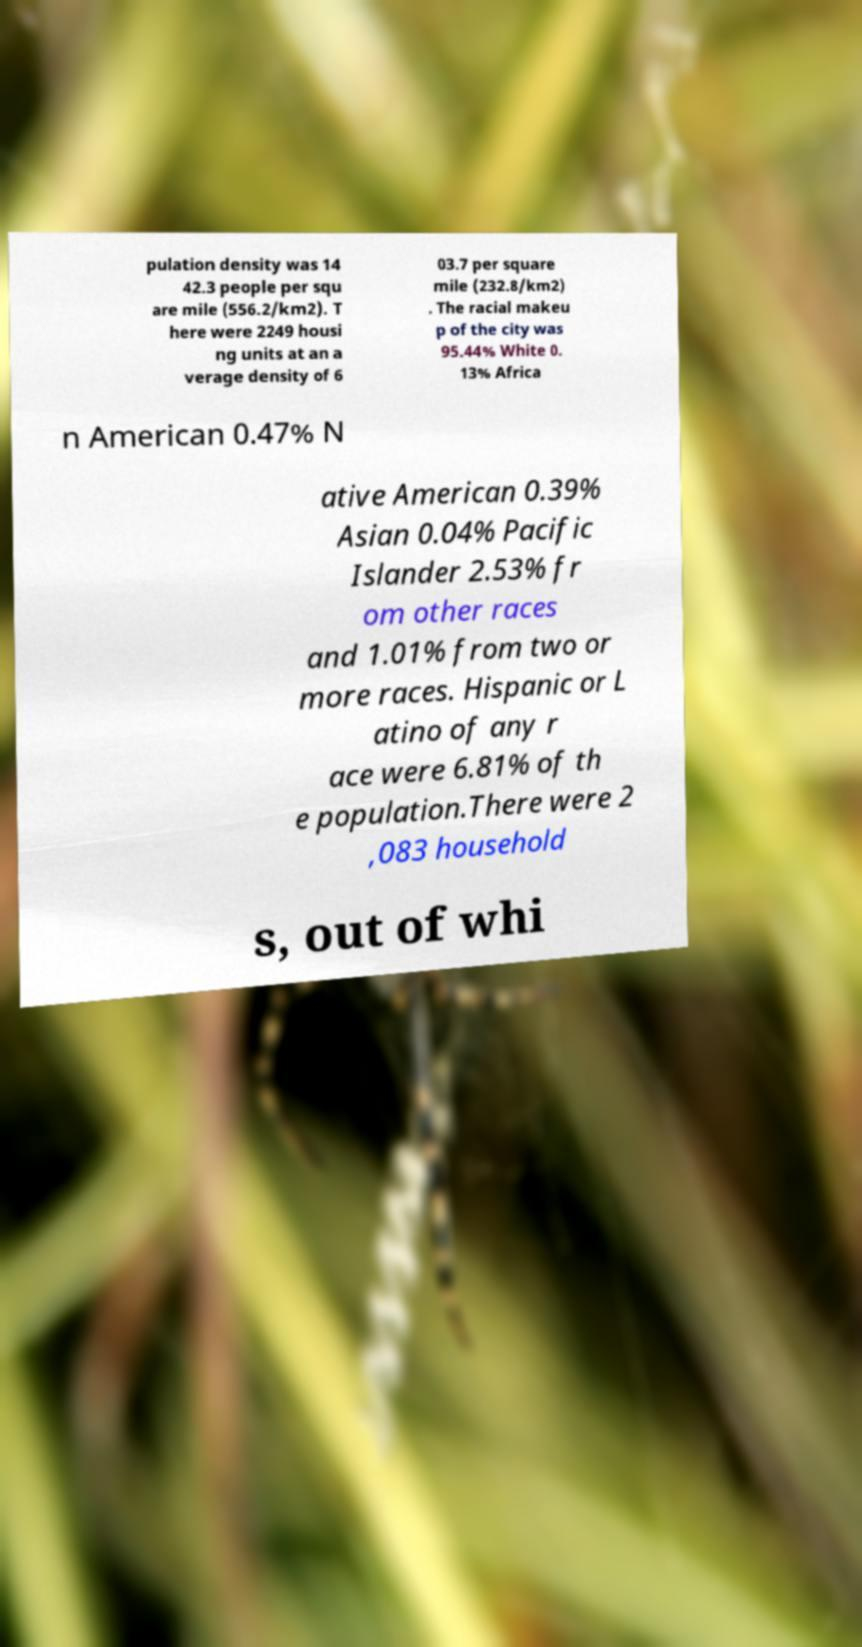Could you extract and type out the text from this image? pulation density was 14 42.3 people per squ are mile (556.2/km2). T here were 2249 housi ng units at an a verage density of 6 03.7 per square mile (232.8/km2) . The racial makeu p of the city was 95.44% White 0. 13% Africa n American 0.47% N ative American 0.39% Asian 0.04% Pacific Islander 2.53% fr om other races and 1.01% from two or more races. Hispanic or L atino of any r ace were 6.81% of th e population.There were 2 ,083 household s, out of whi 